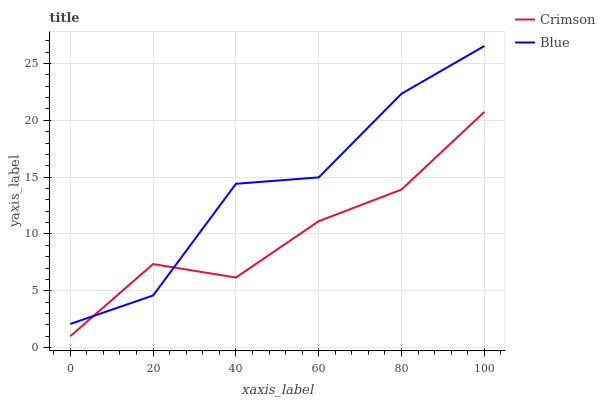Does Crimson have the minimum area under the curve?
Answer yes or no. Yes. Does Blue have the maximum area under the curve?
Answer yes or no. Yes. Does Blue have the minimum area under the curve?
Answer yes or no. No. Is Crimson the smoothest?
Answer yes or no. Yes. Is Blue the roughest?
Answer yes or no. Yes. Is Blue the smoothest?
Answer yes or no. No. Does Crimson have the lowest value?
Answer yes or no. Yes. Does Blue have the lowest value?
Answer yes or no. No. Does Blue have the highest value?
Answer yes or no. Yes. Does Crimson intersect Blue?
Answer yes or no. Yes. Is Crimson less than Blue?
Answer yes or no. No. Is Crimson greater than Blue?
Answer yes or no. No. 